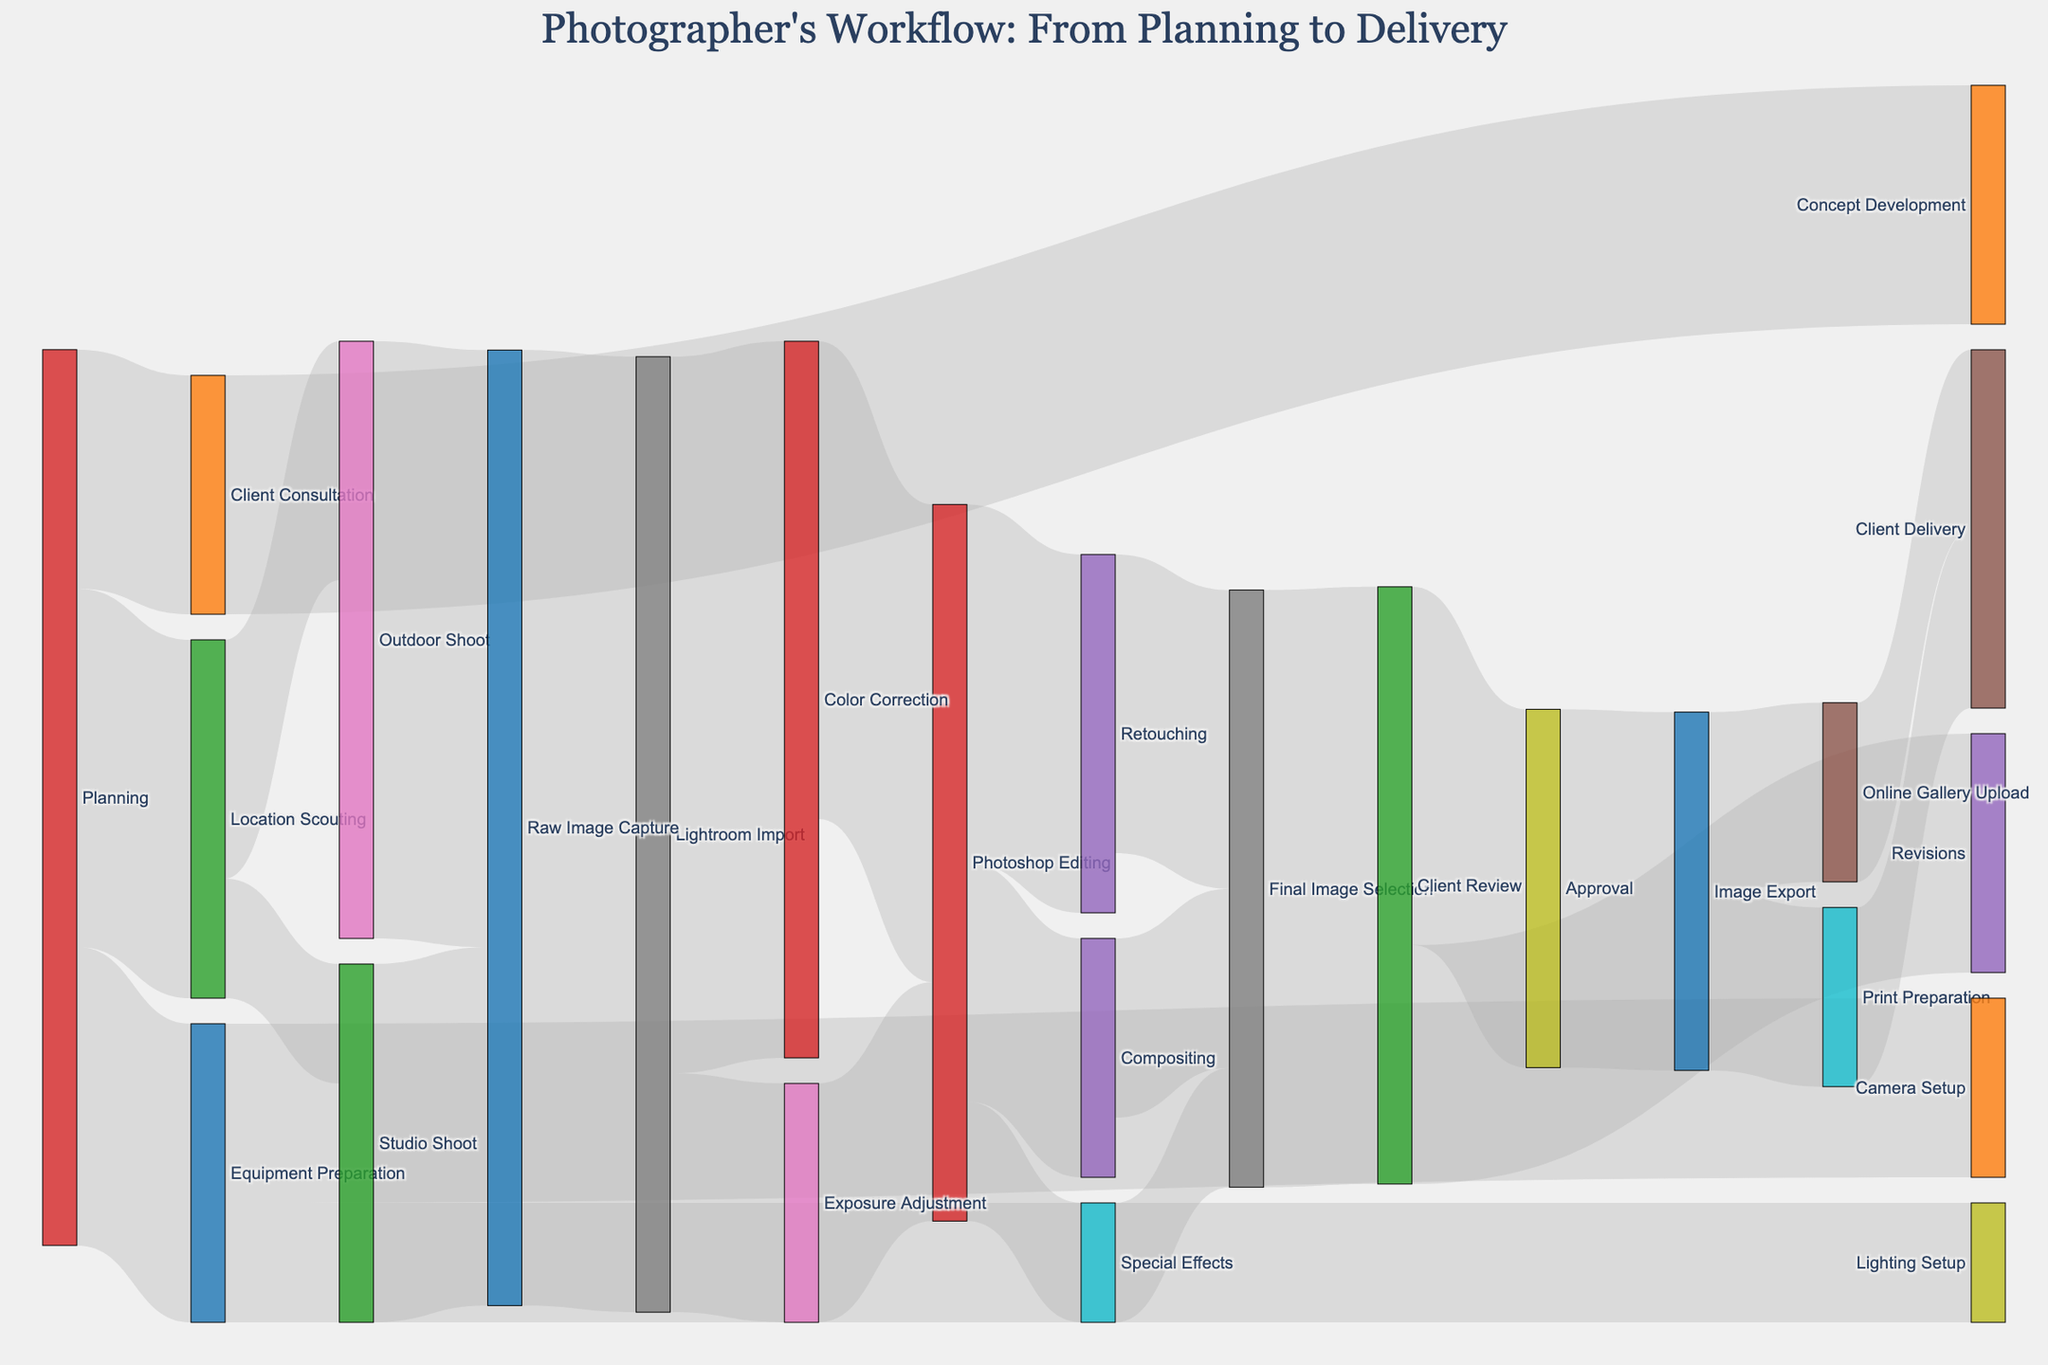What's the total number of steps in the workflow? The workflow has various steps from different origins. Counting all nodes will give us the total number of steps. There are 21 unique steps listed in the diagram.
Answer: 21 What is the first step in this workflow? By looking at the nodes and the direction of the arrows, the first step is "Planning."
Answer: Planning How many steps are involved in the Planning phase? From the Planning node, there are arrows leading to three steps: Location Scouting, Equipment Preparation, and Client Consultation.
Answer: 3 Which phase has the most connections coming into it? By observing the arrows, the "Lightroom Import" phase has the most connections coming into it, which are Raw Image Capture (Outdoor Shoot and Studio Shoot). Each of these two send 40 and 20 respectively.
Answer: Lightroom Import What are the two phases with equal connections going to the Final Image Selection? By observing the nodes and arrows, Retouching and Compositing each send connections to the Final Image Selection.
Answer: Retouching and Compositing What are the values (in number) assigned to Revisions and Approval at the Client Review phase? The Client Review node has outgoing connections to Revisions and Approval. Revisions have a value of 20, and Approval has a value of 30.
Answer: Revisions: 20, Approval: 30 How does the number of images uploaded in the Online Gallery compare to those prepared for Print? Both Online Gallery Upload and Print Preparation have the same values leading to Client Delivery, which is 15.
Answer: Equal Which steps follow Photoshop Editing directly? The arrows following Photoshop Editing lead to Retouching, Compositing, and Special Effects.
Answer: Retouching, Compositing, Special Effects What is the sum of values for steps directly following Equipment Preparation? Equipment Preparation leads to Camera Setup (15) and Lighting Setup (10). Summing these gives 15 + 10 = 25.
Answer: 25 Which step has the highest value connection following an Outdoor Shoot? Outdoor Shoot connects only to Raw Image Capture with a value of 50, the highest connection.
Answer: Raw Image Capture 